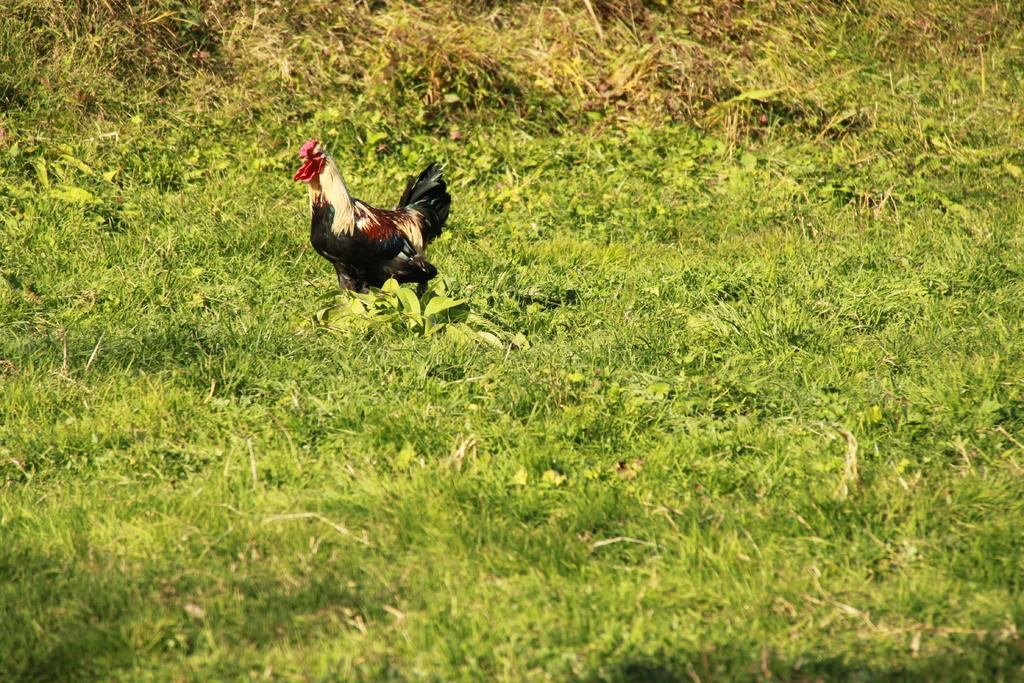What type of animal is in the image? There is a cock in the image. Where is the cock located? The cock is on a grassland. What type of garden can be seen in the image? There is no garden present in the image; it features a cock on a grassland. What type of net is being used by the cock in the image? There is no net present in the image, and the cock is not using any net. 